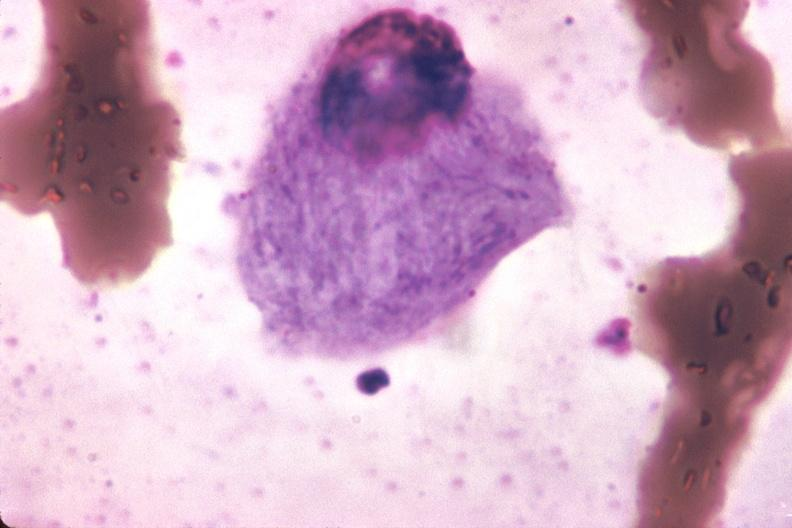s lower chest and abdomen anterior present?
Answer the question using a single word or phrase. No 